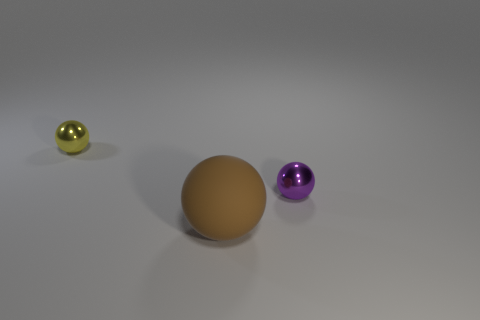There is another metal object that is the same size as the yellow shiny object; what is its shape?
Ensure brevity in your answer.  Sphere. Are there more purple metal objects than tiny purple blocks?
Your answer should be very brief. Yes. What material is the ball that is behind the large brown rubber sphere and to the left of the purple metal thing?
Your response must be concise. Metal. How many other objects are there of the same material as the purple ball?
Make the answer very short. 1. What number of tiny spheres have the same color as the big matte object?
Provide a short and direct response. 0. What is the size of the metal object in front of the shiny sphere that is left of the small shiny ball that is to the right of the yellow sphere?
Your response must be concise. Small. What number of shiny things are either small gray balls or large things?
Keep it short and to the point. 0. There is a yellow object; is its shape the same as the small metal thing to the right of the big matte sphere?
Keep it short and to the point. Yes. Are there more small balls that are on the left side of the big brown matte object than yellow shiny balls on the right side of the tiny yellow metal thing?
Ensure brevity in your answer.  Yes. Is there any other thing of the same color as the rubber thing?
Ensure brevity in your answer.  No. 